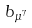<formula> <loc_0><loc_0><loc_500><loc_500>b _ { \mu ^ { 7 } }</formula> 